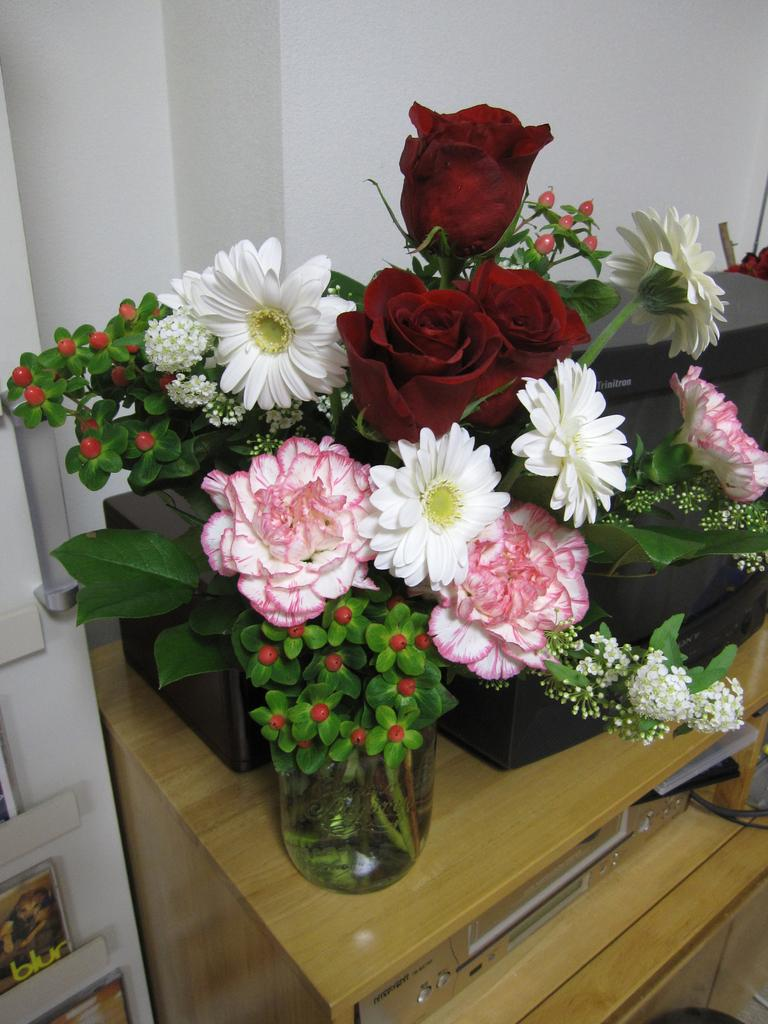What is the main object in the center of the image? There is a desktop in the center of the image. What can be seen on the desktop? There is a flower vase on a stand on the desktop. What is visible in the background of the image? There are boards and a wall visible in the background of the image. What type of pump is connected to the wall in the image? There is no pump connected to the wall in the image; it only features a desktop, a flower vase on a stand, boards, and a wall in the background. 